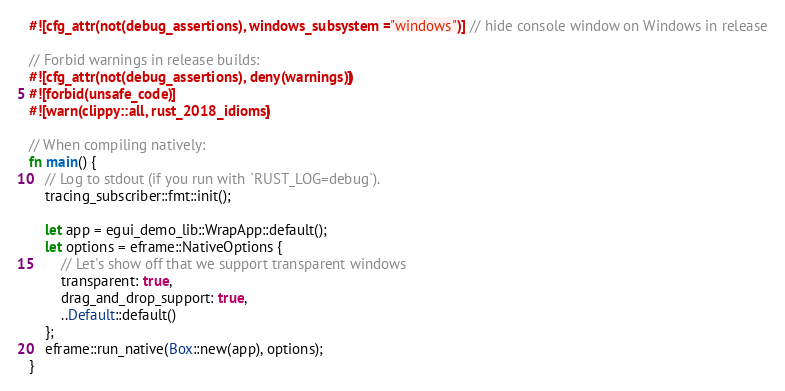Convert code to text. <code><loc_0><loc_0><loc_500><loc_500><_Rust_>#![cfg_attr(not(debug_assertions), windows_subsystem = "windows")] // hide console window on Windows in release

// Forbid warnings in release builds:
#![cfg_attr(not(debug_assertions), deny(warnings))]
#![forbid(unsafe_code)]
#![warn(clippy::all, rust_2018_idioms)]

// When compiling natively:
fn main() {
    // Log to stdout (if you run with `RUST_LOG=debug`).
    tracing_subscriber::fmt::init();

    let app = egui_demo_lib::WrapApp::default();
    let options = eframe::NativeOptions {
        // Let's show off that we support transparent windows
        transparent: true,
        drag_and_drop_support: true,
        ..Default::default()
    };
    eframe::run_native(Box::new(app), options);
}
</code> 